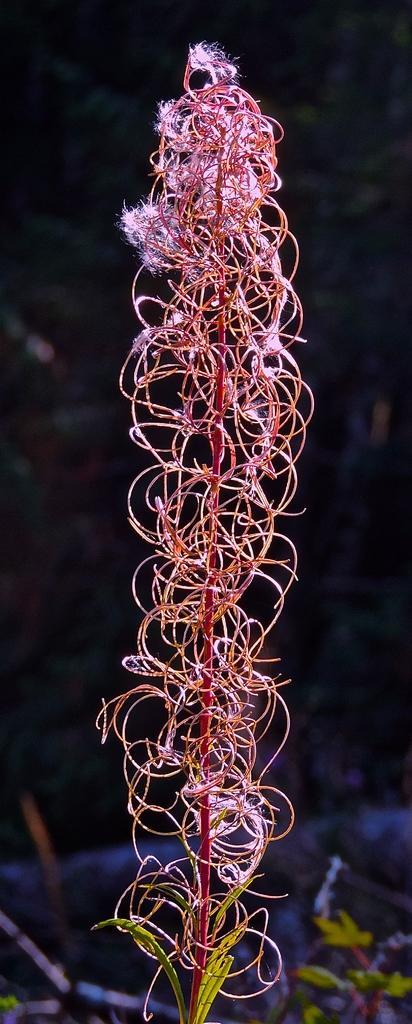In one or two sentences, can you explain what this image depicts? There is a plant having pink color flowers. In the background, there is a plant. And the background is dark in color. 